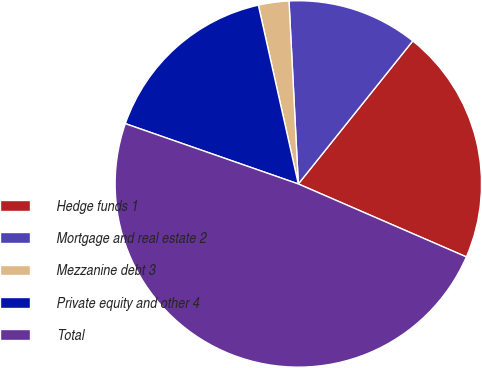<chart> <loc_0><loc_0><loc_500><loc_500><pie_chart><fcel>Hedge funds 1<fcel>Mortgage and real estate 2<fcel>Mezzanine debt 3<fcel>Private equity and other 4<fcel>Total<nl><fcel>20.78%<fcel>11.55%<fcel>2.69%<fcel>16.16%<fcel>48.82%<nl></chart> 